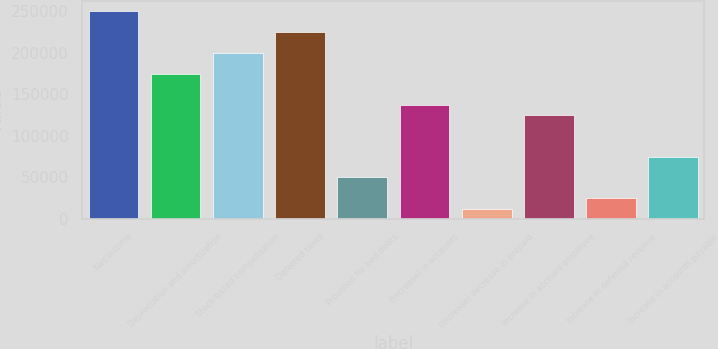<chart> <loc_0><loc_0><loc_500><loc_500><bar_chart><fcel>Net income<fcel>Depreciation and amortization<fcel>Stock-based compensation<fcel>Deferred taxes<fcel>Provision for bad debts<fcel>(Increase) in accounts<fcel>(Increase) decrease in prepaid<fcel>Increase in accrued employee<fcel>Increase in deferred revenue<fcel>Increase in accounts payable<nl><fcel>249956<fcel>174979<fcel>199971<fcel>224964<fcel>50016.8<fcel>137490<fcel>12528.2<fcel>124994<fcel>25024.4<fcel>75009.2<nl></chart> 